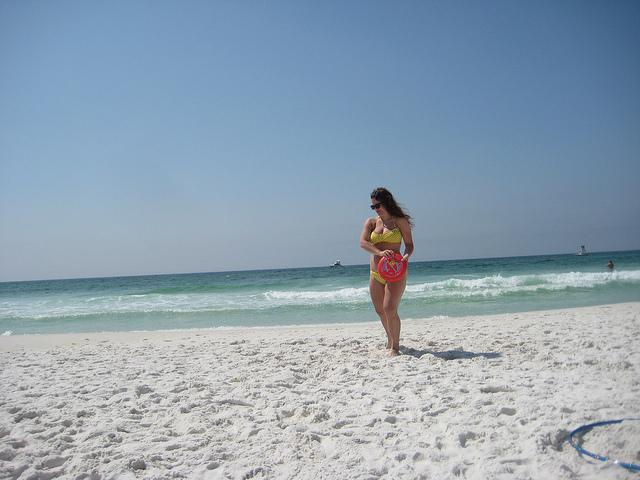What is the woman going to do?
Concise answer only. Throw frisbee. What color is the Frisbee?
Quick response, please. Red. Are the woman's feet wet?
Concise answer only. No. What is in the picture?
Be succinct. Woman. Do her swimsuit pieces match?
Write a very short answer. Yes. Is this lady good enough to surf?
Short answer required. Yes. What is the person holding?
Answer briefly. Frisbee. What is she holding?
Concise answer only. Frisbee. What color is the woman's blouse?
Be succinct. Yellow. How many people are in the water?
Quick response, please. 1. What color is her bikini?
Give a very brief answer. Yellow. What is the woman holding on her right hand?
Short answer required. Frisbee. What is the girl in the photo about to do?
Short answer required. Throw frisbee. What is she walking on?
Be succinct. Sand. How many people are walking on the beach?
Answer briefly. 1. 